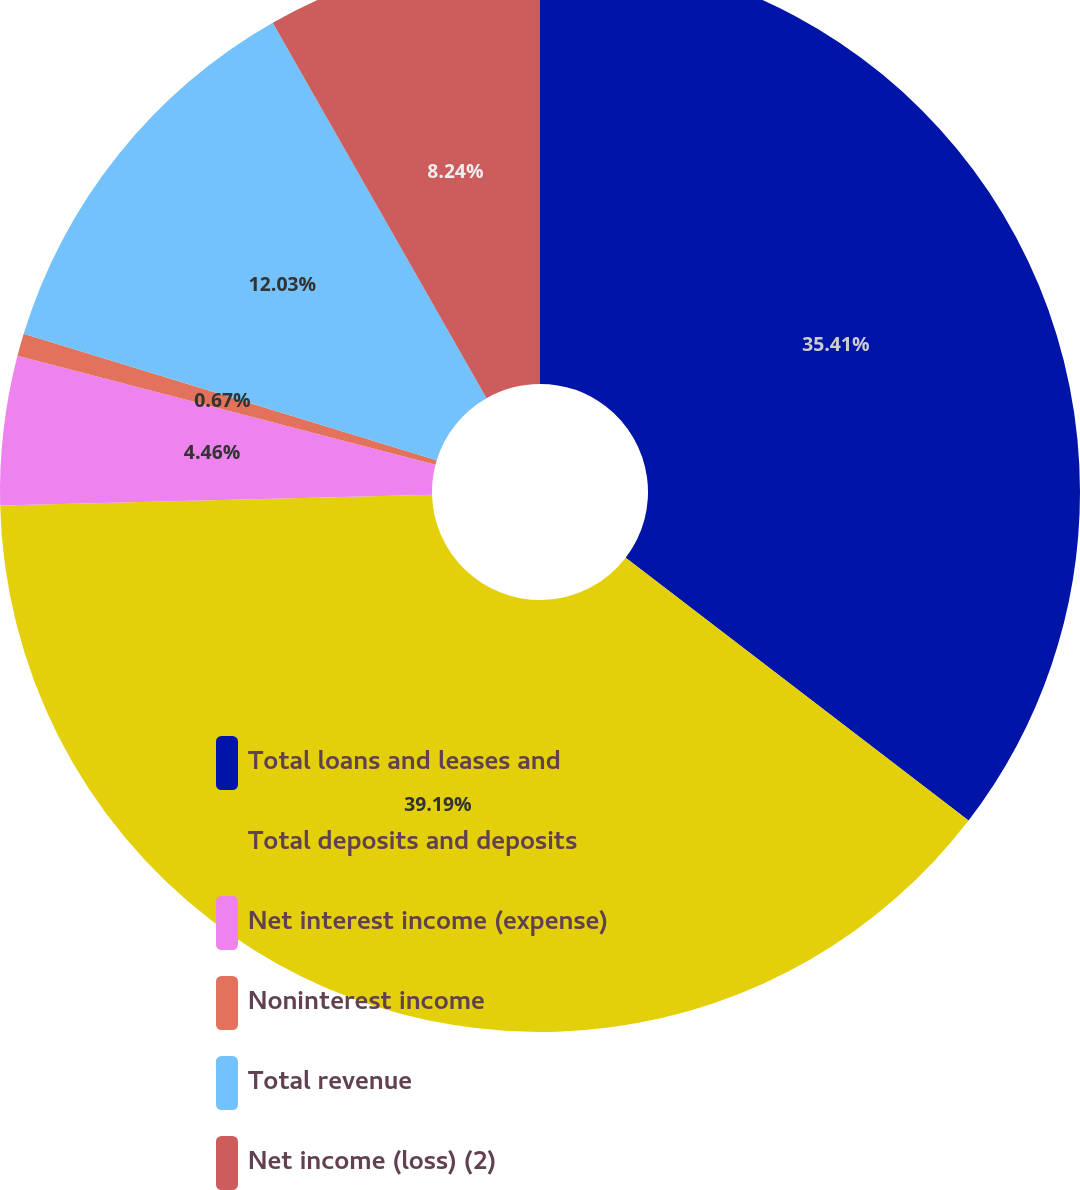Convert chart to OTSL. <chart><loc_0><loc_0><loc_500><loc_500><pie_chart><fcel>Total loans and leases and<fcel>Total deposits and deposits<fcel>Net interest income (expense)<fcel>Noninterest income<fcel>Total revenue<fcel>Net income (loss) (2)<nl><fcel>35.41%<fcel>39.19%<fcel>4.46%<fcel>0.67%<fcel>12.03%<fcel>8.24%<nl></chart> 